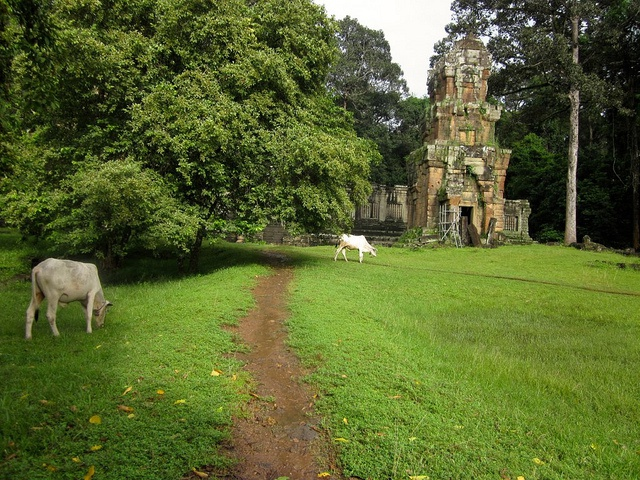Describe the objects in this image and their specific colors. I can see cow in darkgreen, gray, and tan tones and cow in darkgreen, ivory, olive, and beige tones in this image. 